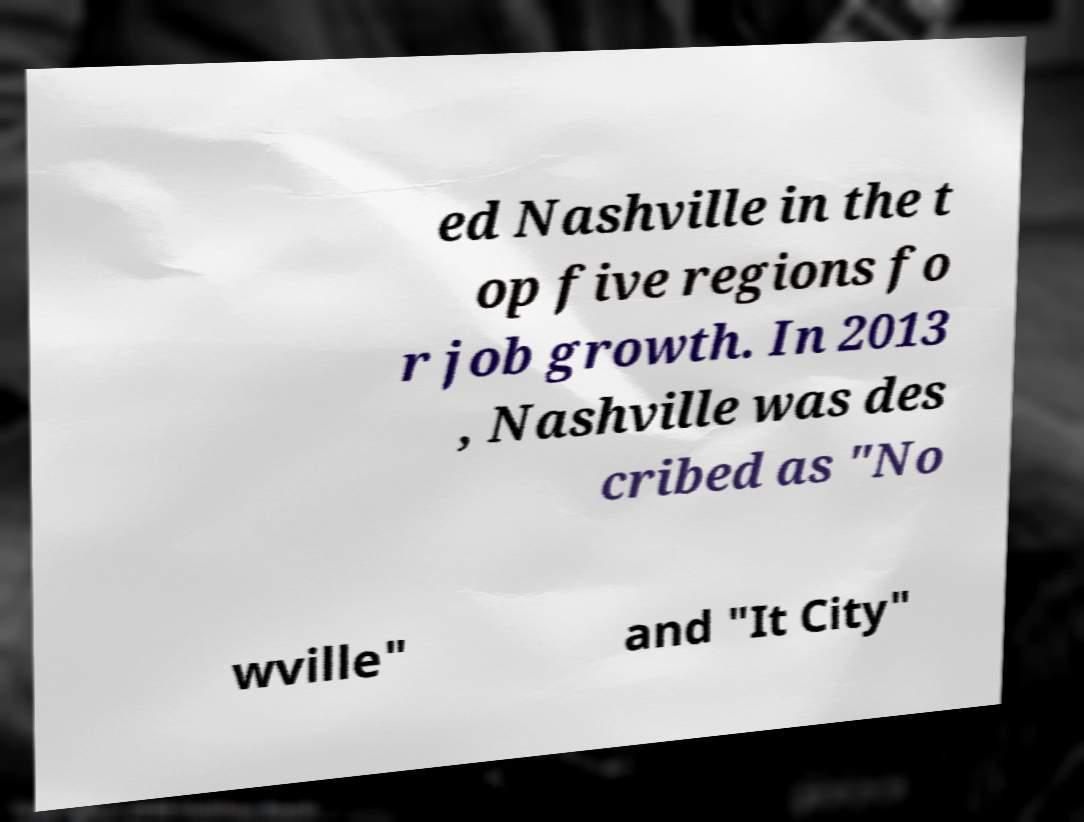Please identify and transcribe the text found in this image. ed Nashville in the t op five regions fo r job growth. In 2013 , Nashville was des cribed as "No wville" and "It City" 